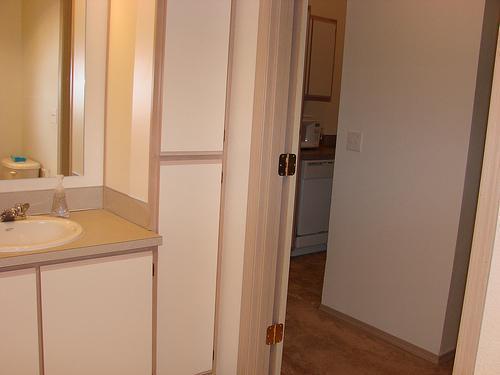How many sinks are shown?
Give a very brief answer. 1. 